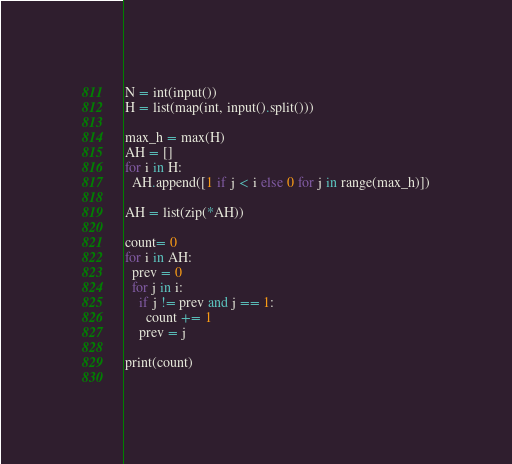<code> <loc_0><loc_0><loc_500><loc_500><_Python_>N = int(input())
H = list(map(int, input().split()))

max_h = max(H)
AH = []
for i in H:
  AH.append([1 if j < i else 0 for j in range(max_h)])
  
AH = list(zip(*AH))

count= 0
for i in AH:
  prev = 0
  for j in i:
    if j != prev and j == 1:
      count += 1
    prev = j

print(count)
  </code> 